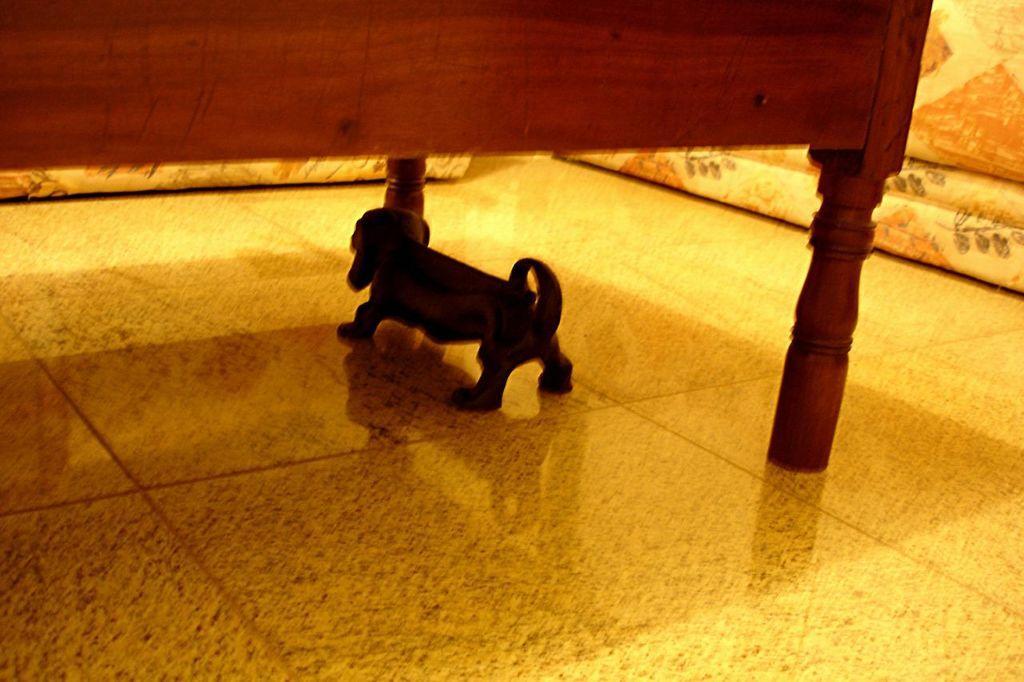Describe this image in one or two sentences. Dog is under the bed. 